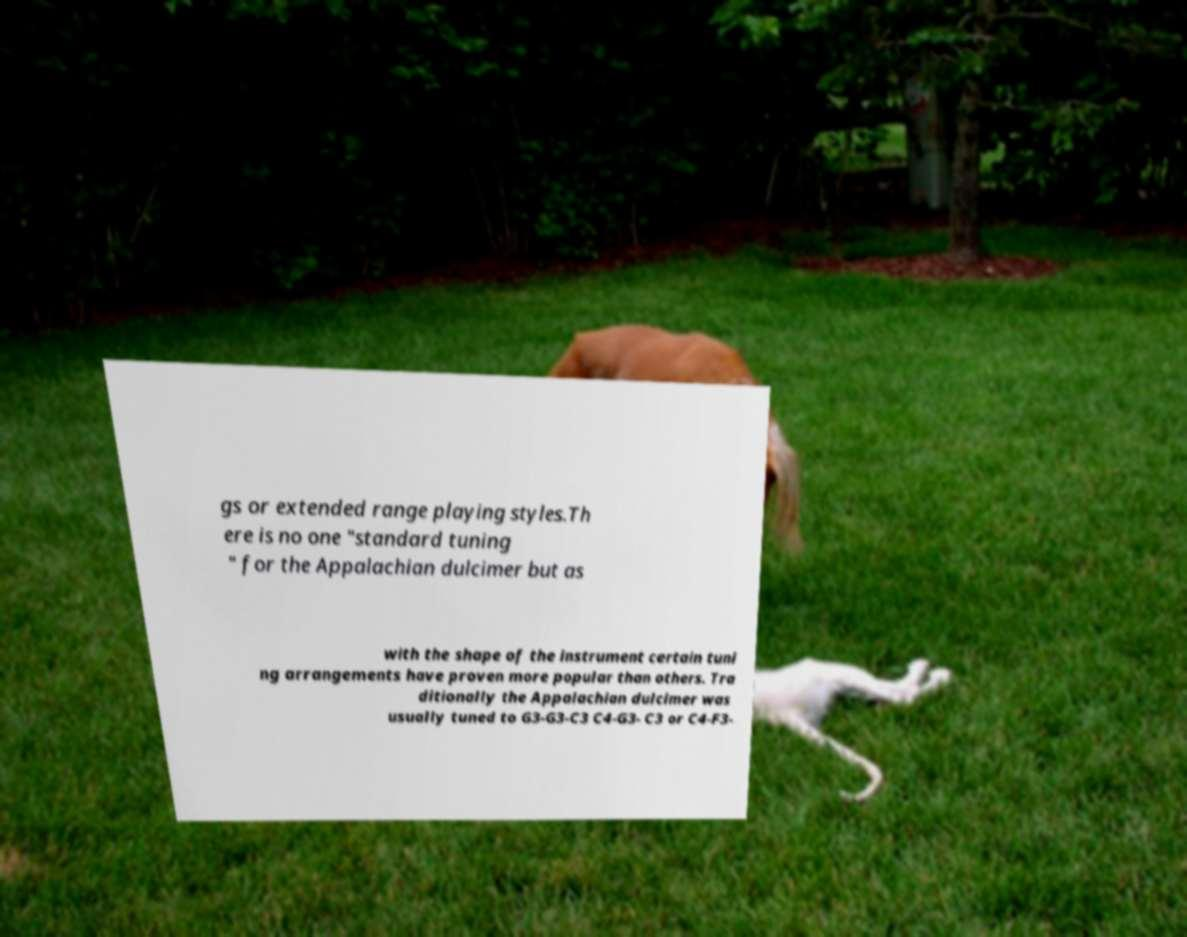Please read and relay the text visible in this image. What does it say? gs or extended range playing styles.Th ere is no one "standard tuning " for the Appalachian dulcimer but as with the shape of the instrument certain tuni ng arrangements have proven more popular than others. Tra ditionally the Appalachian dulcimer was usually tuned to G3-G3-C3 C4-G3- C3 or C4-F3- 